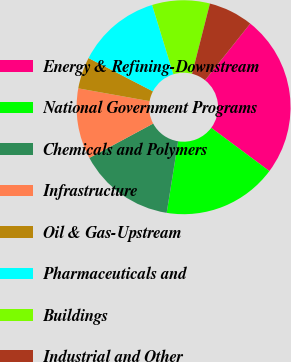Convert chart to OTSL. <chart><loc_0><loc_0><loc_500><loc_500><pie_chart><fcel>Energy & Refining-Downstream<fcel>National Government Programs<fcel>Chemicals and Polymers<fcel>Infrastructure<fcel>Oil & Gas-Upstream<fcel>Pharmaceuticals and<fcel>Buildings<fcel>Industrial and Other<nl><fcel>24.47%<fcel>17.34%<fcel>14.62%<fcel>10.68%<fcel>4.78%<fcel>12.65%<fcel>8.71%<fcel>6.75%<nl></chart> 